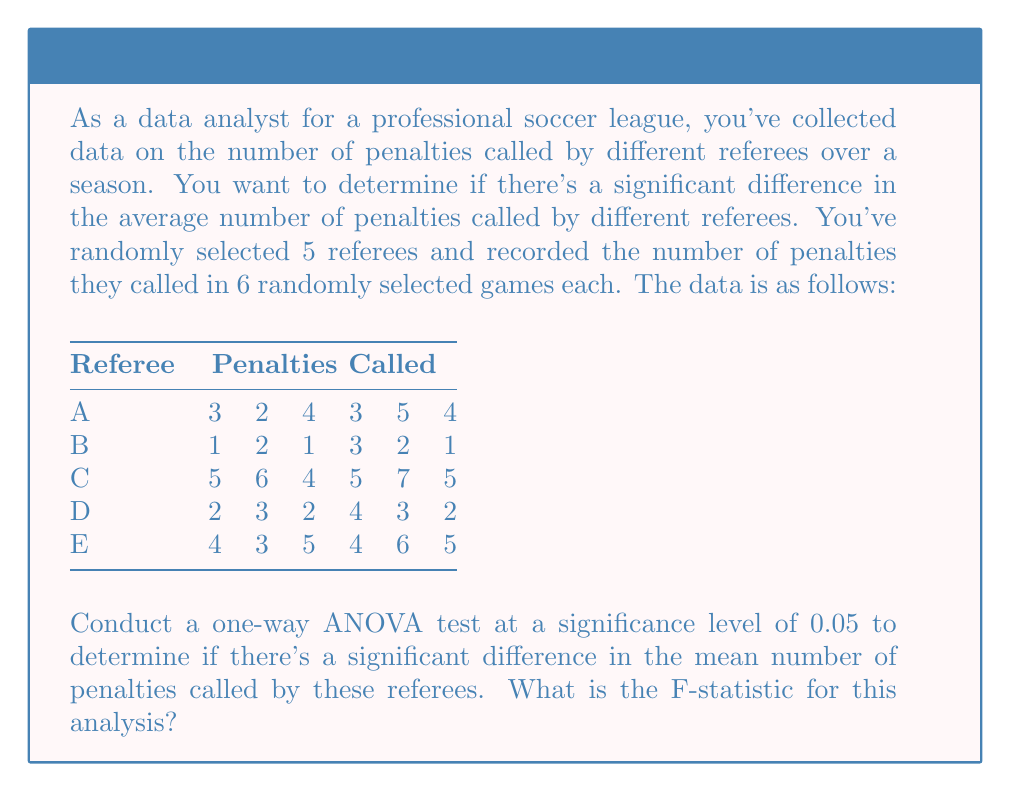What is the answer to this math problem? To conduct a one-way ANOVA, we need to follow these steps:

1. Calculate the overall mean:
   $$\bar{X} = \frac{\text{Sum of all observations}}{\text{Total number of observations}} = \frac{90}{30} = 3$$

2. Calculate the Sum of Squares Total (SST):
   $$SST = \sum_{i=1}^{n} (X_i - \bar{X})^2 = 108$$

3. Calculate the Sum of Squares Between groups (SSB):
   $$SSB = \sum_{i=1}^{k} n_i(\bar{X}_i - \bar{X})^2$$
   where $k$ is the number of groups (referees), $n_i$ is the number of observations in each group, and $\bar{X}_i$ is the mean of each group.
   
   Group means:
   Referee A: 3.5
   Referee B: 1.67
   Referee C: 5.33
   Referee D: 2.67
   Referee E: 4.5

   $$SSB = 6[(3.5 - 3)^2 + (1.67 - 3)^2 + (5.33 - 3)^2 + (2.67 - 3)^2 + (4.5 - 3)^2] = 81.33$$

4. Calculate the Sum of Squares Within groups (SSW):
   $$SSW = SST - SSB = 108 - 81.33 = 26.67$$

5. Calculate degrees of freedom:
   Between groups: $df_B = k - 1 = 5 - 1 = 4$
   Within groups: $df_W = N - k = 30 - 5 = 25$

6. Calculate Mean Square Between (MSB) and Mean Square Within (MSW):
   $$MSB = \frac{SSB}{df_B} = \frac{81.33}{4} = 20.33$$
   $$MSW = \frac{SSW}{df_W} = \frac{26.67}{25} = 1.07$$

7. Calculate the F-statistic:
   $$F = \frac{MSB}{MSW} = \frac{20.33}{1.07} = 19.00$$

Therefore, the F-statistic for this analysis is 19.00.
Answer: 19.00 